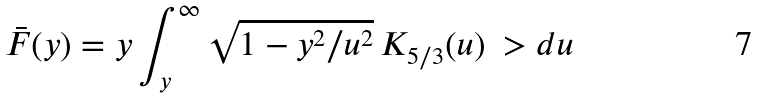<formula> <loc_0><loc_0><loc_500><loc_500>\bar { F } ( y ) = y \int _ { y } ^ { \infty } \sqrt { 1 - y ^ { 2 } / u ^ { 2 } } \, K _ { 5 / 3 } ( u ) \ > d u</formula> 